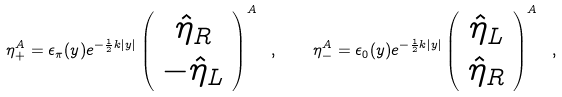Convert formula to latex. <formula><loc_0><loc_0><loc_500><loc_500>\eta _ { + } ^ { A } = \epsilon _ { \pi } ( y ) e ^ { - \frac { 1 } { 2 } k | y | } \left ( \begin{array} { c } { { \hat { \eta } _ { R } } } \\ { { - \hat { \eta } _ { L } } } \end{array} \right ) ^ { A } \ , \quad \eta _ { - } ^ { A } = \epsilon _ { 0 } ( y ) e ^ { - \frac { 1 } { 2 } k | y | } \left ( \begin{array} { c } { { \hat { \eta } _ { L } } } \\ { { \hat { \eta } _ { R } } } \end{array} \right ) ^ { A } \ ,</formula> 